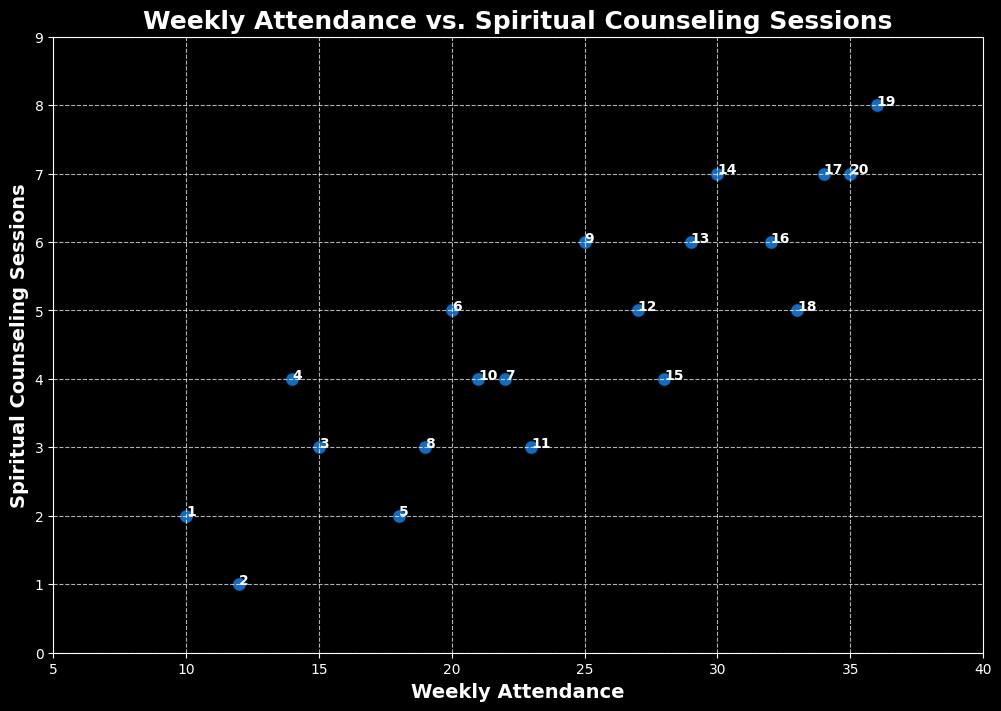what is the correlation between weekly attendance and spiritual counseling sessions? To determine the correlation, visually observe the trend of points. If the points appear to follow a pattern, you can infer correlation. Observing the scatter plot, the points incline upward, implying a positive relationship. As weekly attendance increases, spiritual counseling sessions also tend to increase.
Answer: Positive which week had the highest number of spiritual counseling sessions, and what was the weekly attendance during that week? Look for the week number located at the point with the highest y-value in the plot (spiritual counseling sessions). Week 19 had the highest number of sessions (8), and the weekly attendance during that week was 36.
Answer: Week 19, 36 how many more spiritual counseling sessions were there in week 17 compared to week 2? Locate the points for week 17 and week 2 and note their y-values. Subtract the number of sessions in week 2 from week 17 (7 - 1 = 6).
Answer: 6 which weeks had the same number of spiritual counseling sessions, and what was the weekly attendance for those weeks? Identify points aligning horizontally (same y-value). Week 3 and week 8 both had 3 sessions (hours attended were 15 and 19).
Answer: Weeks 3 & 8; 15 & 19 is there any week where the number of spiritual counseling sessions was twice the weekly attendance? Check if any points align with a ratio of 2 between y (sessions) and x (attendance). No such point exists in the plot.
Answer: No what is the approximate median weekly attendance from the scatter plot? Arrange the weekly attendance values in ascending order and find the middle value. The sorted attendance values are [10, 12, 14, 15, 18, 19, 20, 21, 22, 23, 25, 27, 28, 29, 30, 32, 33, 34, 35, 36]. The median value (average of 20th and 21st value) is (23+25)/2=24.
Answer: 24 